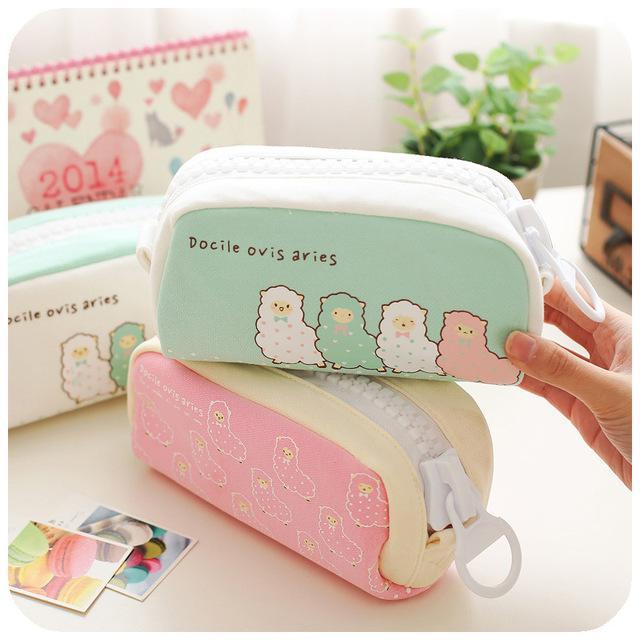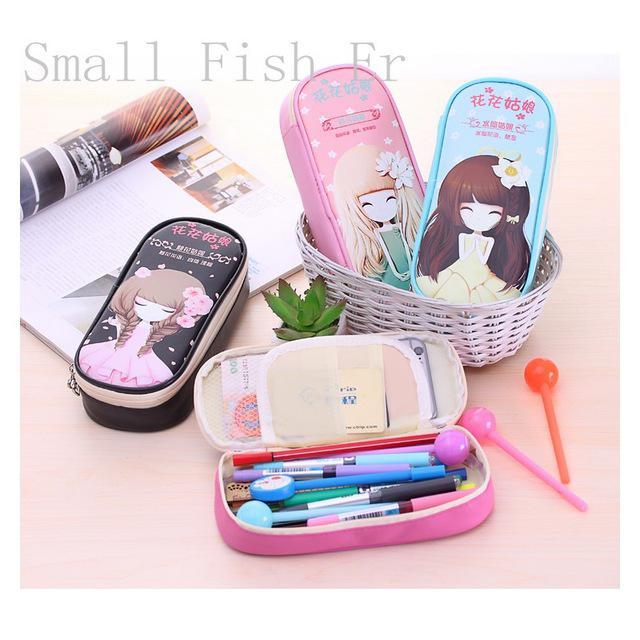The first image is the image on the left, the second image is the image on the right. For the images displayed, is the sentence "One image shows at least four cases in different solid colors with rounded edges, and only one is open and filled with supplies." factually correct? Answer yes or no. No. The first image is the image on the left, the second image is the image on the right. Evaluate the accuracy of this statement regarding the images: "There is one image that includes only pencil cases zipped closed, and none are open.". Is it true? Answer yes or no. Yes. 